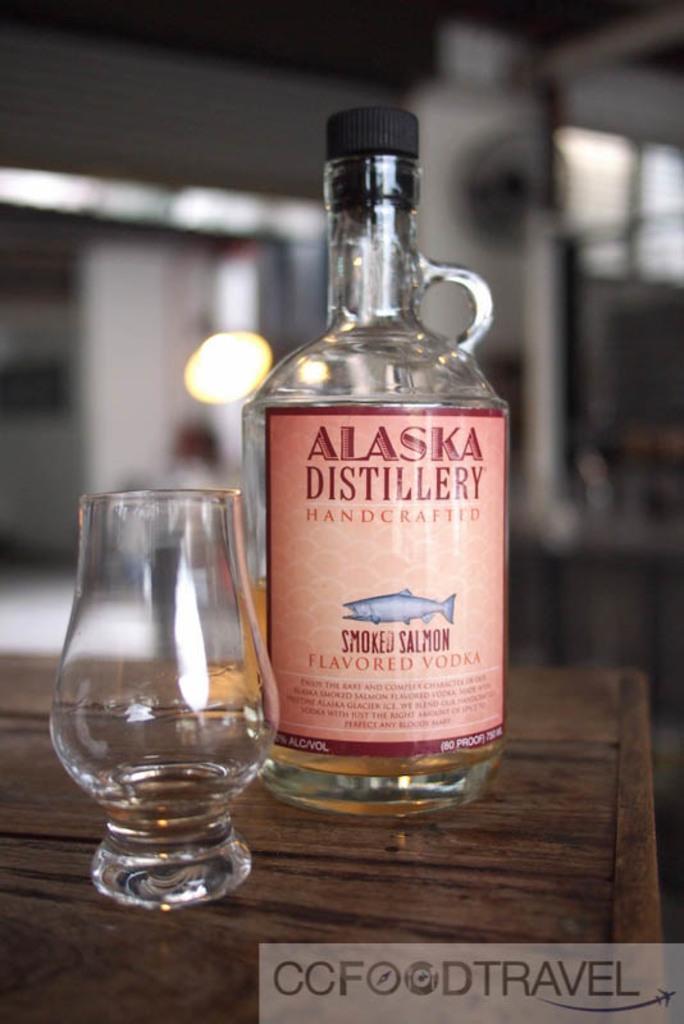Can you describe this image briefly? This is a picture of a bottle and a glass on the table and on the bottle it is written as alaska distillery handcrafted smoked salmon flavored vodka and the lid is in black color. 